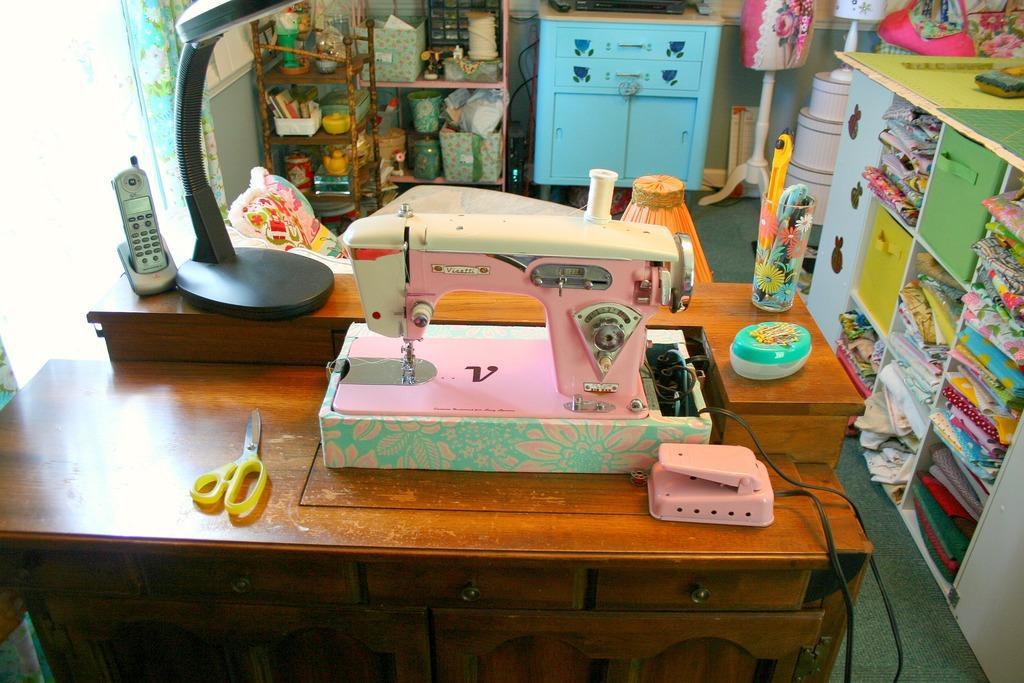How would you summarize this image in a sentence or two? In this image, we can see a teller-machine and scissor on the table and there are some dress in the cuboid and on the left side we can see a telephone. 